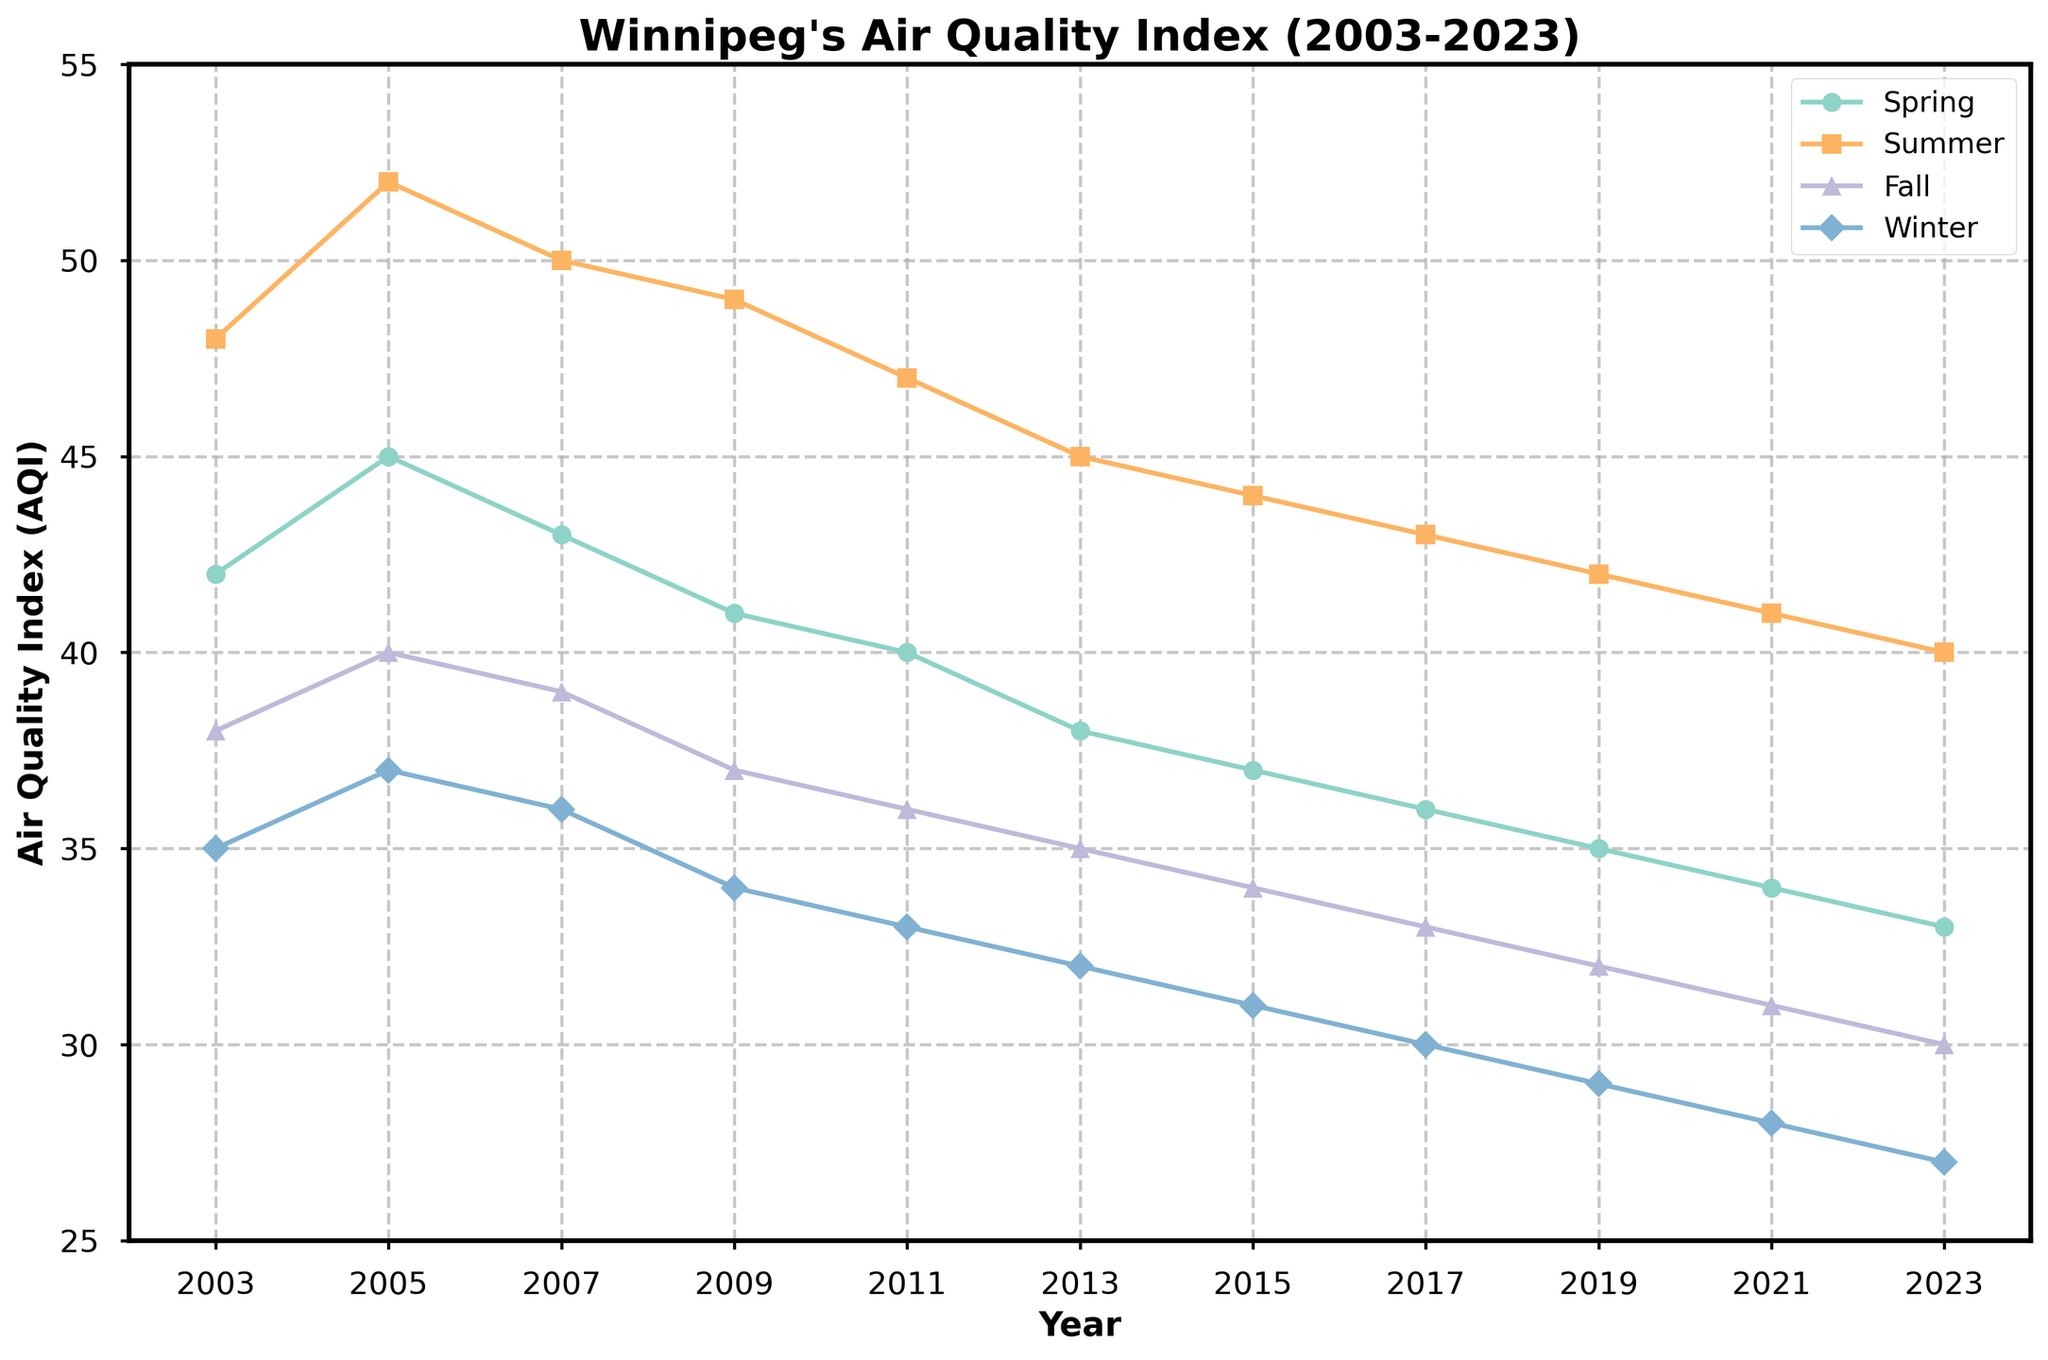What is the general trend of Winnipeg's air quality index (AQI) from 2003 to 2023? Across all seasons, the AQI generally decreases over the 20-year period from 2003 to 2023.
Answer: Decreasing Which season consistently shows the highest AQI values over the years? Summer consistently shows the highest AQI values when compared across all seasons for each year.
Answer: Summer Which year had the lowest winter AQI value, and what was the value? The year 2023 had the lowest winter AQI value, which was 27.
Answer: 2023, 27 By how many units did the summer AQI value decrease from 2003 to 2023? The summer AQI in 2003 was 48, and in 2023 it was 40. The decrease is calculated as 48 - 40.
Answer: 8 units Compare the AQI values for spring in 2005 and 2023. Which year had a better (lower) air quality, and by how many units? The spring AQI in 2005 was 45, and in 2023 it was 33. The difference is 45 - 33. So, 2023 had better air quality by 12 units.
Answer: 2023, 12 units On average, which season has the best (lowest) AQI values? By averaging the AQI values across all years for each season, winter generally has the lowest values: [(35 + 37 + 36 + 34 + 33 + 32 + 31 + 30 + 29 + 28 + 27)/11 = 32.09]. Winter has the best (lowest) AQI.
Answer: Winter What is the average AQI for fall season over the 20 years? Sum all fall AQI values and divide by the number of years: (38 + 40 + 39 + 37 + 36 + 35 + 34 + 33 + 32 + 31 + 30)/11. This results in an average AQI of 35.27.
Answer: 35.27 How does the AQI in winter 2023 compare to winter 2003, and what is the change in AQI units? The AQI in winter 2023 is 27, and in 2003 it was 35. The change is calculated as 35 - 27.
Answer: Decreased by 8 units Which year shows the most significant drop in the spring AQI from the previous recorded year? Examining the differences: 
2005-2003: 45-42 = 3
2007-2005: 43-45 = -2
2009-2007: 41-43 = -2
2011-2009: 40-41 = -1
2013-2011: 38-40 = -2
2015-2013: 37-38 = -1
2017-2015: 36-37 = -1
2019-2017: 35-36 = -1
2021-2019: 34-35 = -1
2023-2021: 33-34 = -1
The spring AQI dropped the most significantly from 2003 to 2005 (3 units).
Answer: 2005, by 3 units Between which years did the summer AQI drop the most significantly, and by how many units? By examining the differences between subsequent years, the most significant drop was between 2013 and 2015: 45 (2013) - 44 (2015) = 1 unit. However, to see a larger difference, consider the longest duration, for instance, 2003 to 2023: 48 to 40 = 8 units.
Answer: 2003-2023, by 8 units 